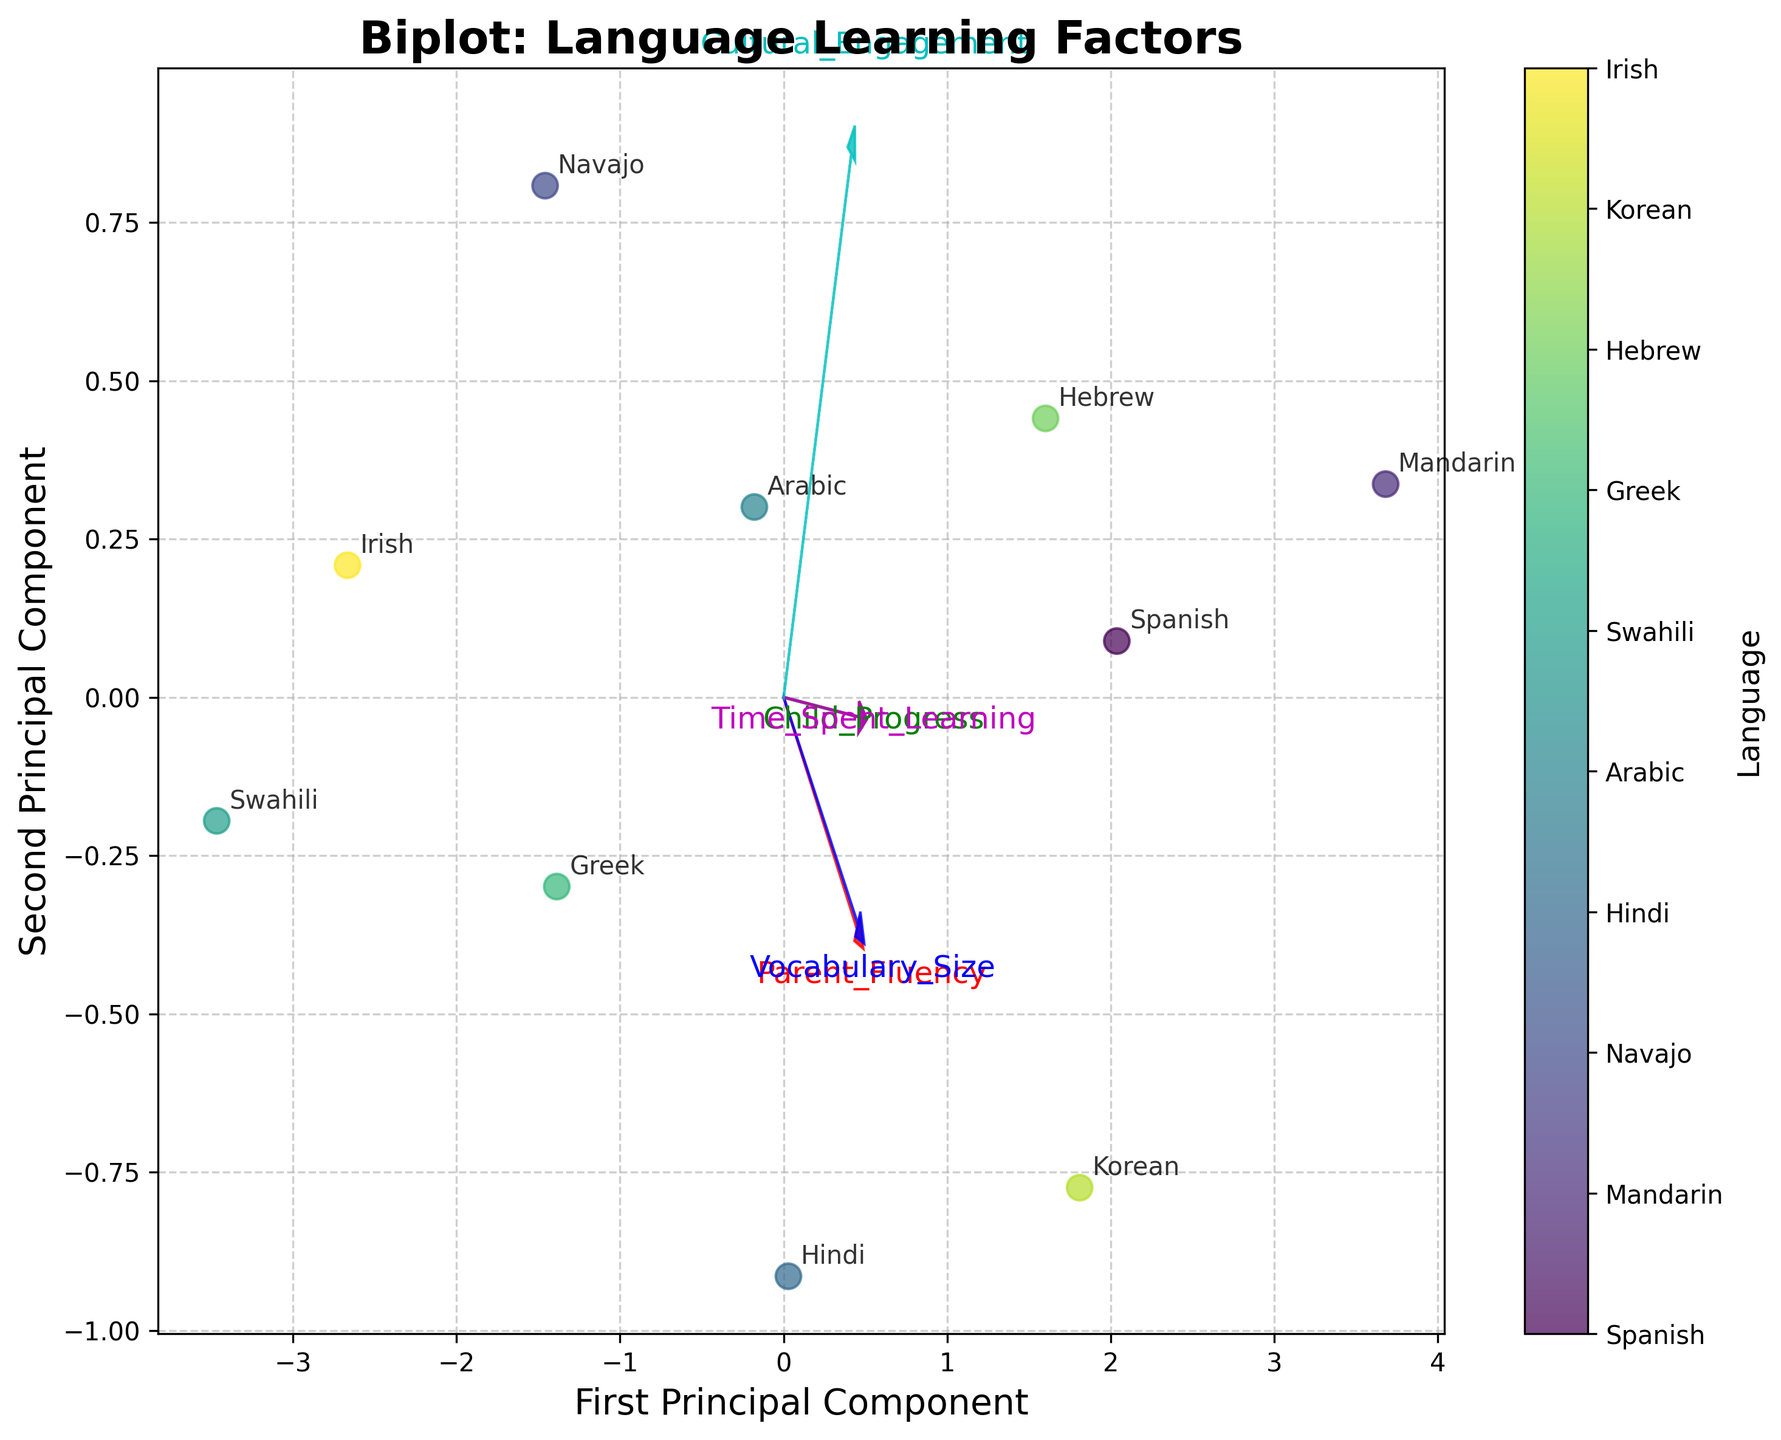what does the title of the plot say? The title of the plot can be found at the top of the figure in larger, bold text. It indicates the main subject of the plot. Here, the title says "Biplot: Language Learning Factors."
Answer: "Biplot: Language Learning Factors." how many axes are labeled on the plot? The plot has two labeled axes. The horizontal axis is labeled "First Principal Component," and the vertical axis is labeled "Second Principal Component."
Answer: two which parental fluency level corresponds to Spanish? Look at the scatter points and the labeled annotation next to them. The annotation "Spanish" corresponds to the scatter point where one of the axes aligns to a value on the scale. According to the data source, the parental fluency level for Spanish is 8.
Answer: 8 what color represents the feature 'Vocabulary_Size' in the feature vectors? Identify the arrows representing the feature vectors and their corresponding text labels. The color of the arrow labeled 'Vocabulary_Size' is blue.
Answer: blue what language has higher child progress: Mandarin or Irish? Locate the data points for Mandarin and Irish and compare the placement of their corresponding "Child_Progress" feature vectors. Mandarin's value for child progress is higher than for Irish.
Answer: Mandarin which feature vector is most aligned with the first principal component? The feature vector that extends the farthest along the "First Principal Component" (horizontal) axis without much deviation towards the "Second Principal Component" (vertical) axis is the one most aligned. In this case, the feature vector for 'Parent_Fluency' or 'Child_Progress' appears mostly aligned with the first component.
Answer: 'Parent_Fluency' or 'Child_Progress' which two languages are closest to each other in the biplot? Compare the annotated scatter points; the two closest points in proximity are "Greek" and "Hebrew." They are situated closest on the plot.
Answer: Greek and Hebrew what is the average cultural engagement score for the languages with the highest and lowest child progress? Find the languages corresponding to the highest and lowest child progress using the data. Then, find their cultural engagement scores. Mandarin (7) has the highest child progress, and Swahili (3) has the lowest. The cultural engagement scores are 8 and 4, respectively. The average is (8+4)/2 = 6.
Answer: 6 which feature vector points in the opposite direction to time spent learning? Observe the direction in which the 'Time_Spent_Learning' vector points. The vector that points in the most opposing direction is 'Swahili,' strongly opposite in terms of directionality.
Answer: 'Swahili' how are the arrows (features) connected in terms of direction and length? In terms of visual alignment and scaling of arrows, the plot depicts certain arrows pointing in the same or differing directions and differing in length due to normalized PCA coefficients' impact. Shorter arrows indicate less variance explained, while longer arrows carry greater significance in the principal component dimensions. Look for 'Parent_Fluency' and 'Child_Progress' most closely aligned.
Answer: 'Parent_Fluency' and 'Child_Progress' 